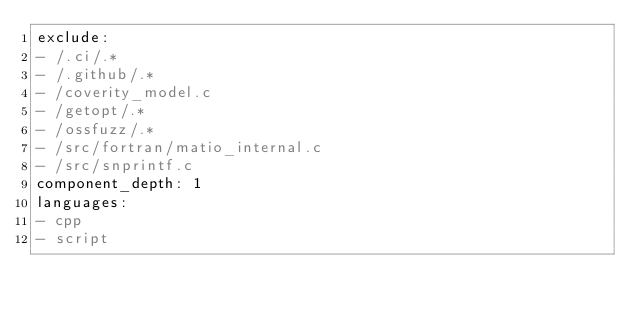<code> <loc_0><loc_0><loc_500><loc_500><_YAML_>exclude:
- /.ci/.*
- /.github/.*
- /coverity_model.c
- /getopt/.*
- /ossfuzz/.*
- /src/fortran/matio_internal.c
- /src/snprintf.c
component_depth: 1
languages:
- cpp
- script
</code> 